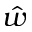<formula> <loc_0><loc_0><loc_500><loc_500>\hat { w }</formula> 